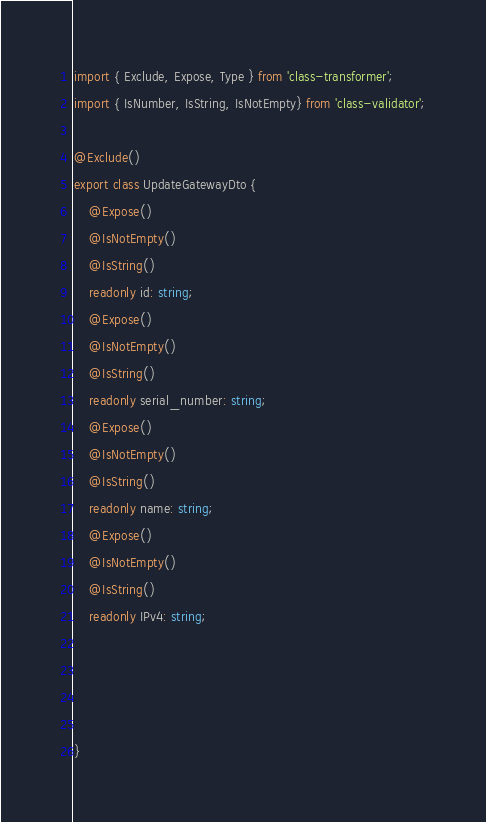Convert code to text. <code><loc_0><loc_0><loc_500><loc_500><_TypeScript_>import { Exclude, Expose, Type } from 'class-transformer';
import { IsNumber, IsString, IsNotEmpty} from 'class-validator';

@Exclude()
export class UpdateGatewayDto {
    @Expose()
    @IsNotEmpty()
    @IsString()
    readonly id: string;
    @Expose()
    @IsNotEmpty()
    @IsString()
    readonly serial_number: string;
    @Expose()
    @IsNotEmpty()
    @IsString()
    readonly name: string;
    @Expose()
    @IsNotEmpty()
    @IsString()
    readonly IPv4: string;
   
    

    
}</code> 